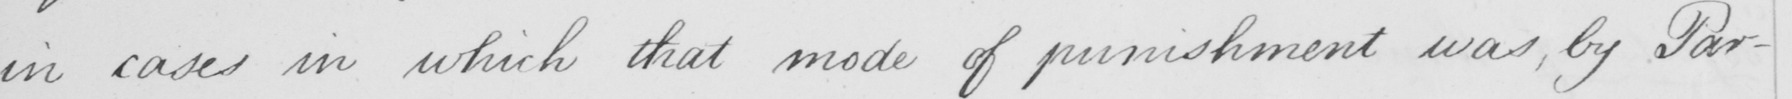Please transcribe the handwritten text in this image. in cases in which that mode of punishment was , by Par- 